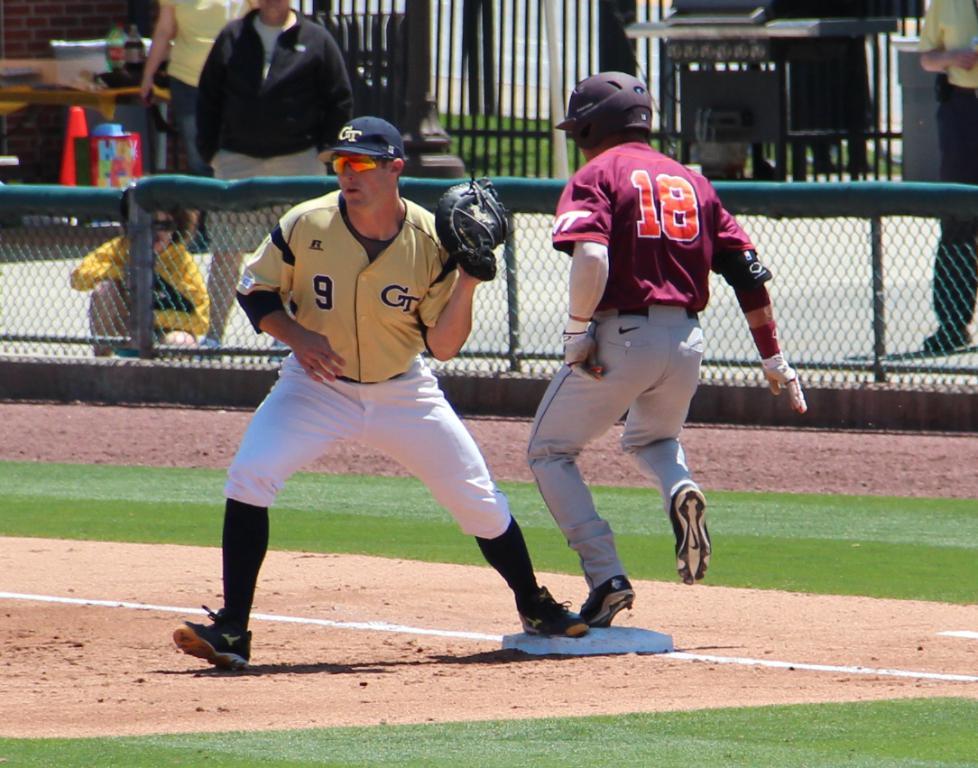What number is the runner?
Give a very brief answer. 18. 